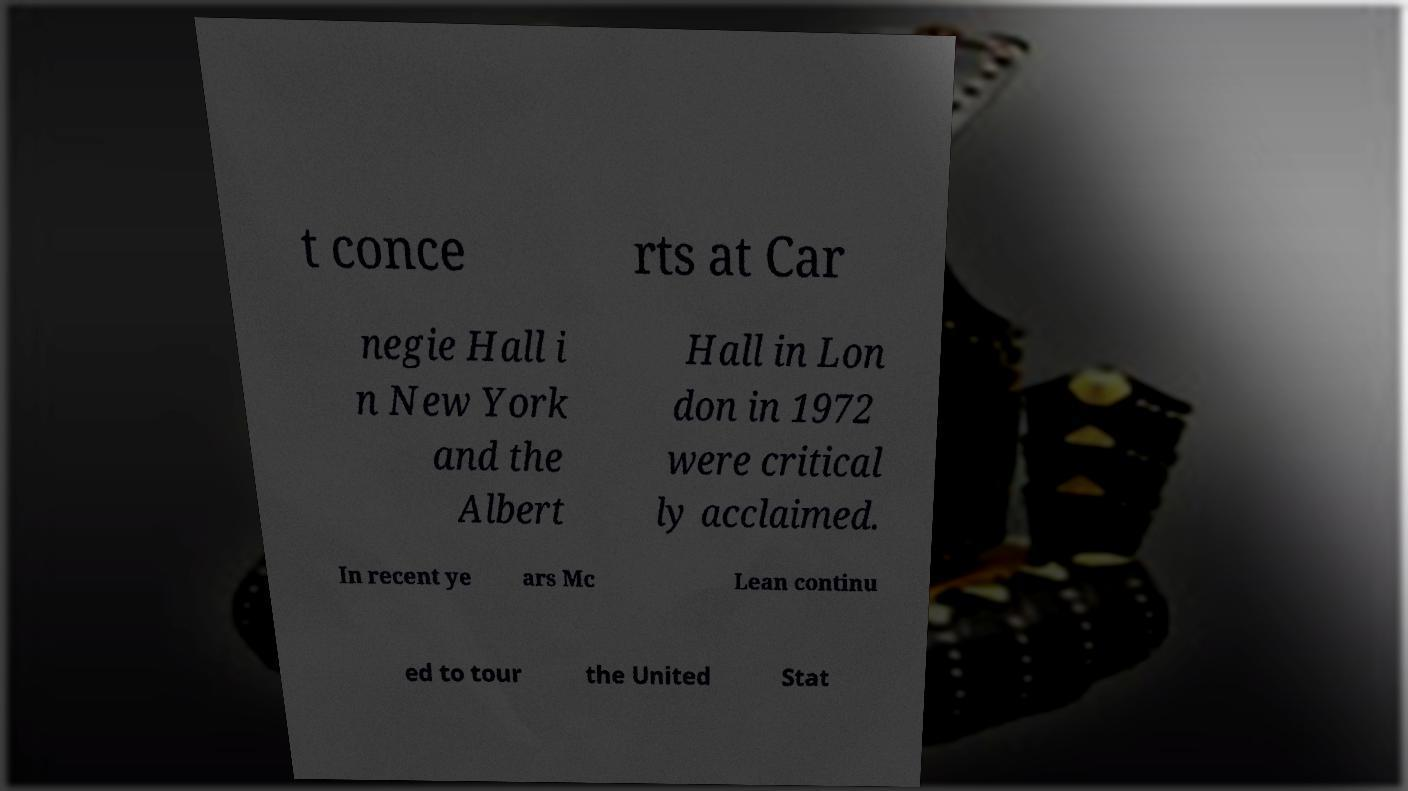Please identify and transcribe the text found in this image. t conce rts at Car negie Hall i n New York and the Albert Hall in Lon don in 1972 were critical ly acclaimed. In recent ye ars Mc Lean continu ed to tour the United Stat 